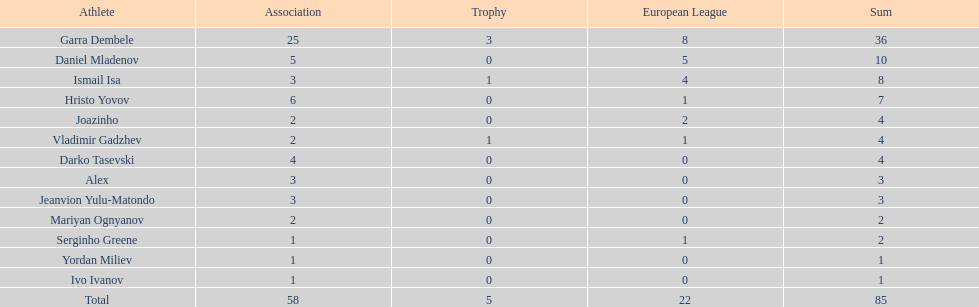Which players only scored one goal? Serginho Greene, Yordan Miliev, Ivo Ivanov. 